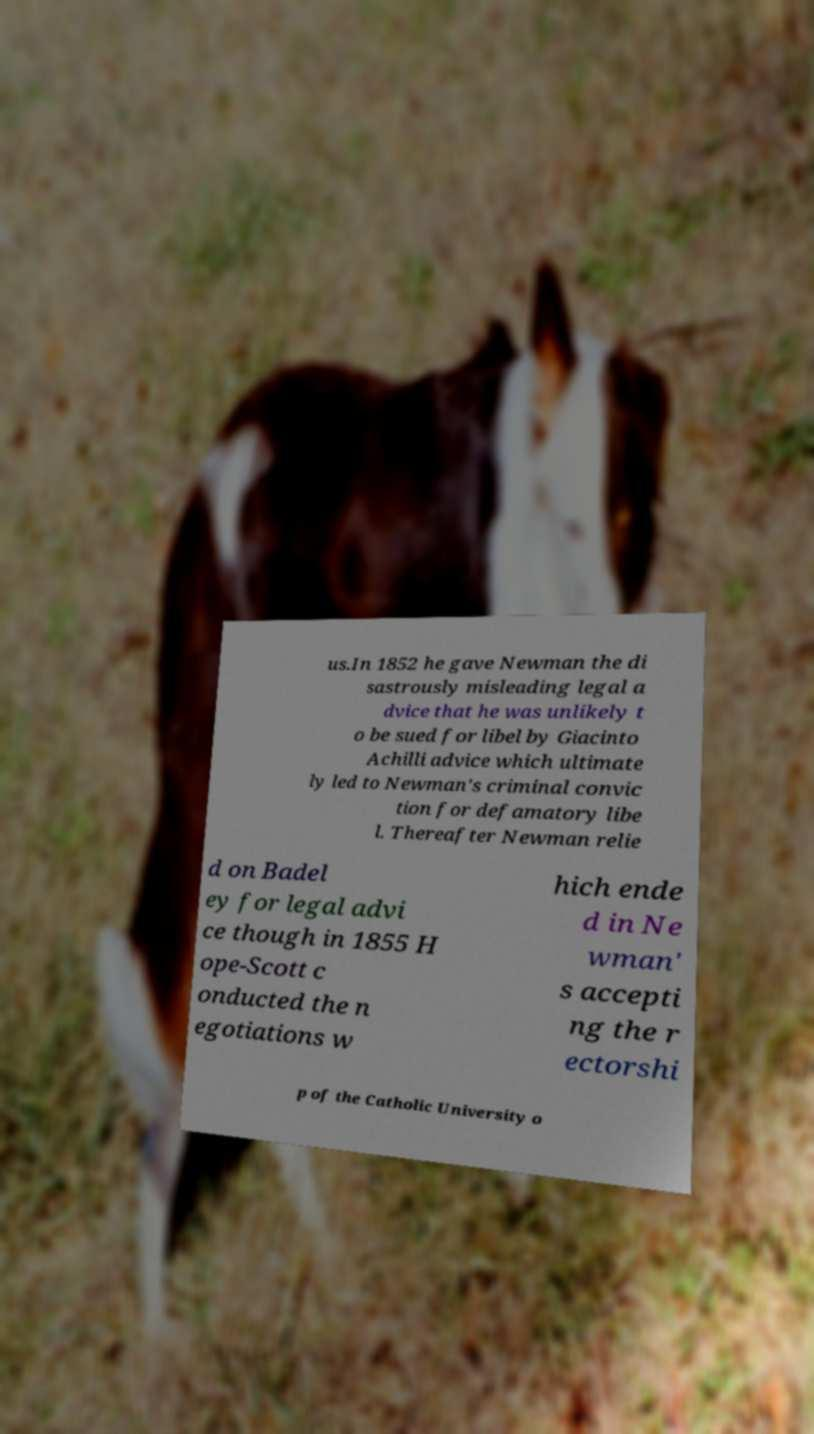Can you accurately transcribe the text from the provided image for me? us.In 1852 he gave Newman the di sastrously misleading legal a dvice that he was unlikely t o be sued for libel by Giacinto Achilli advice which ultimate ly led to Newman's criminal convic tion for defamatory libe l. Thereafter Newman relie d on Badel ey for legal advi ce though in 1855 H ope-Scott c onducted the n egotiations w hich ende d in Ne wman' s accepti ng the r ectorshi p of the Catholic University o 